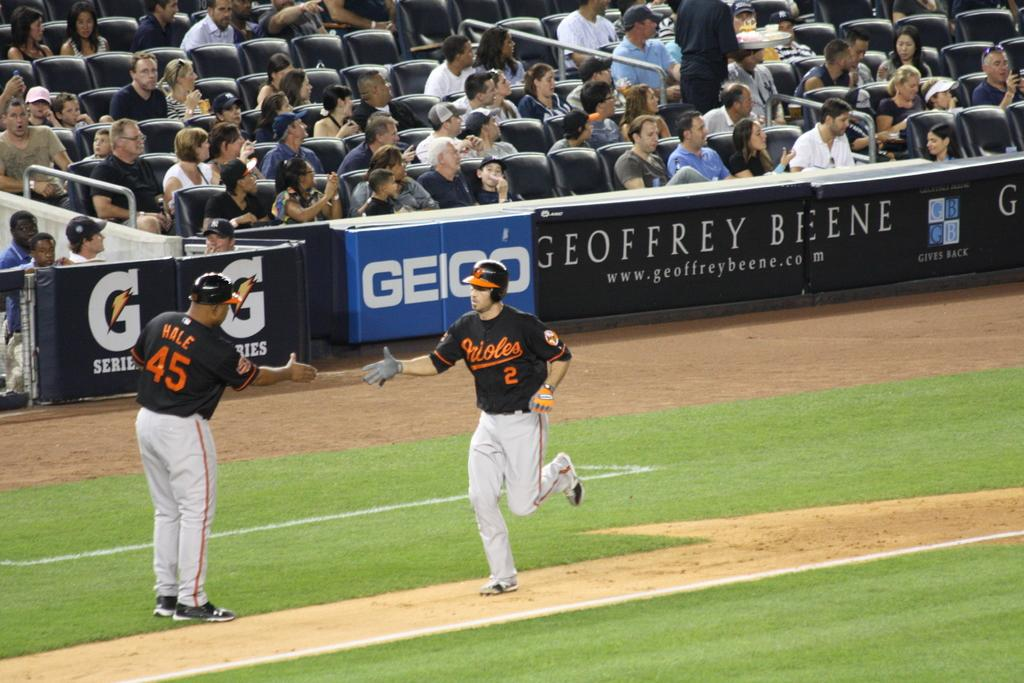<image>
Offer a succinct explanation of the picture presented. An Orioles player wearing the number of 2 running towards home plate being greeted by a teammate. 